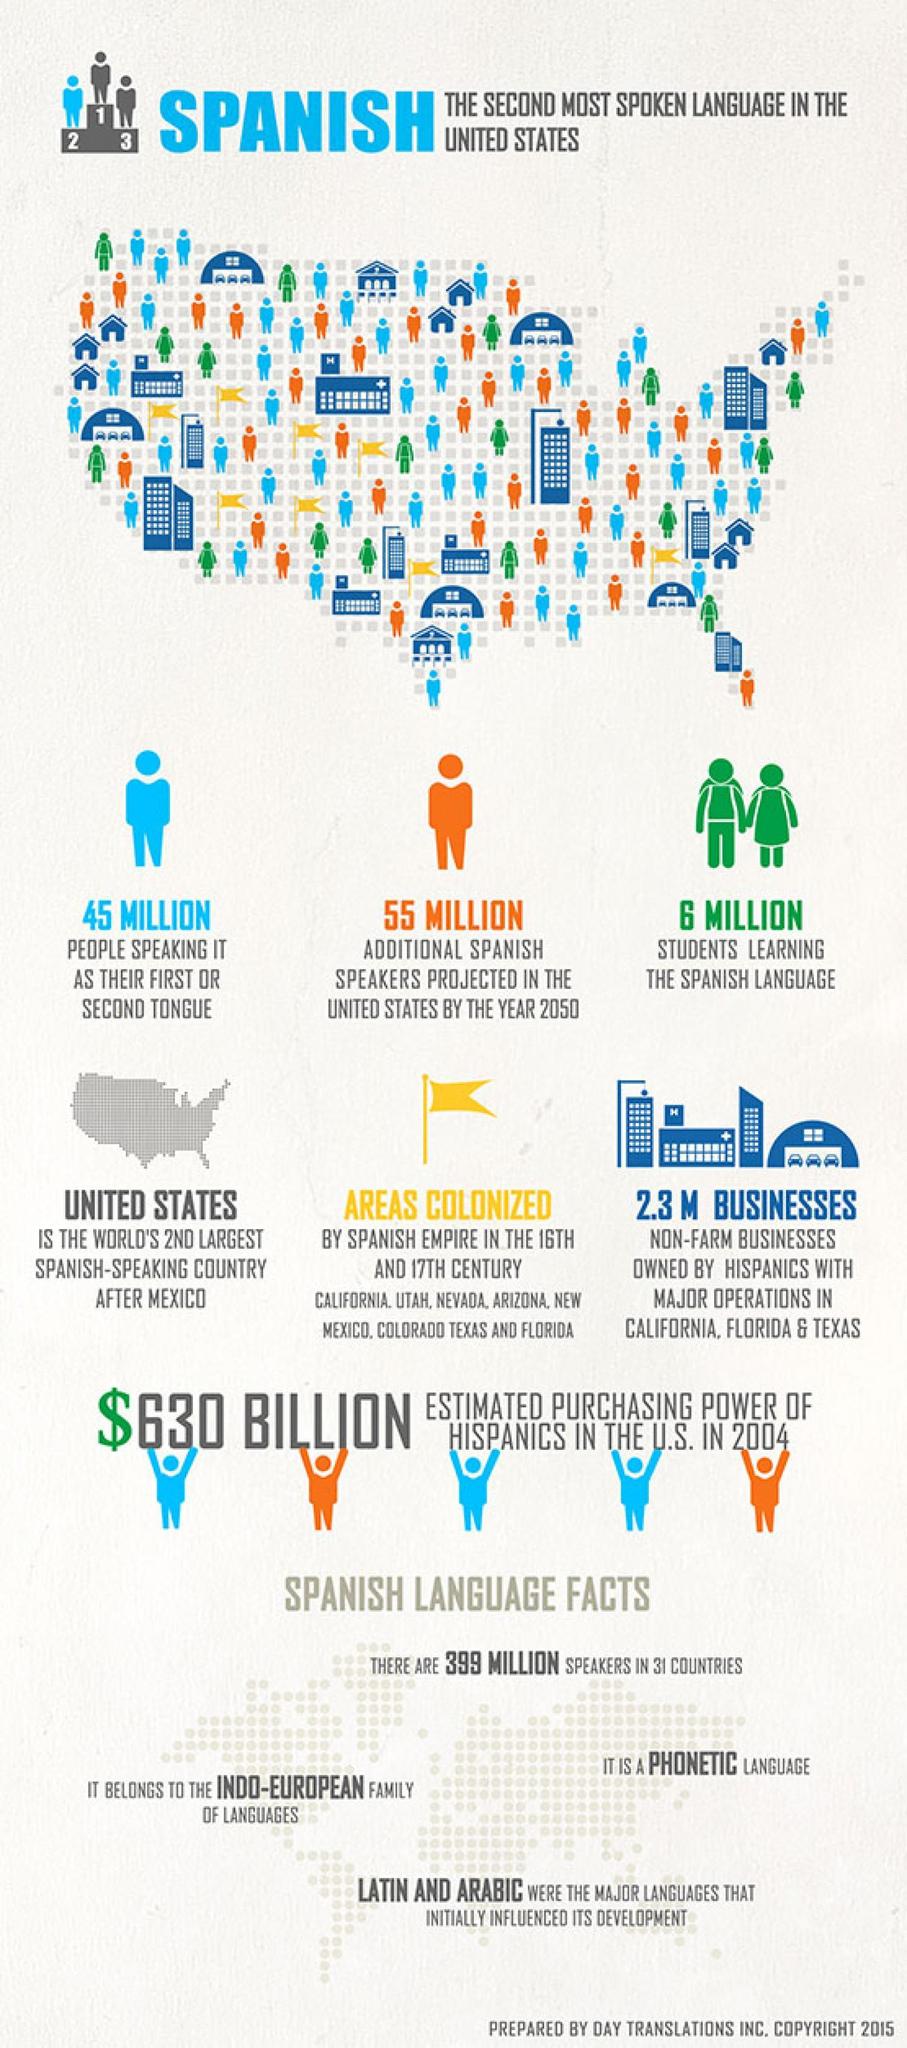which country is the second largest spanish speaking country after Mexico?
Answer the question with a short phrase. united states what is the colour of the flag shown in the picture, yellow or green? yellow how many million people are considering spanish language as their first or second language, 45 or 55 million? 45 million 